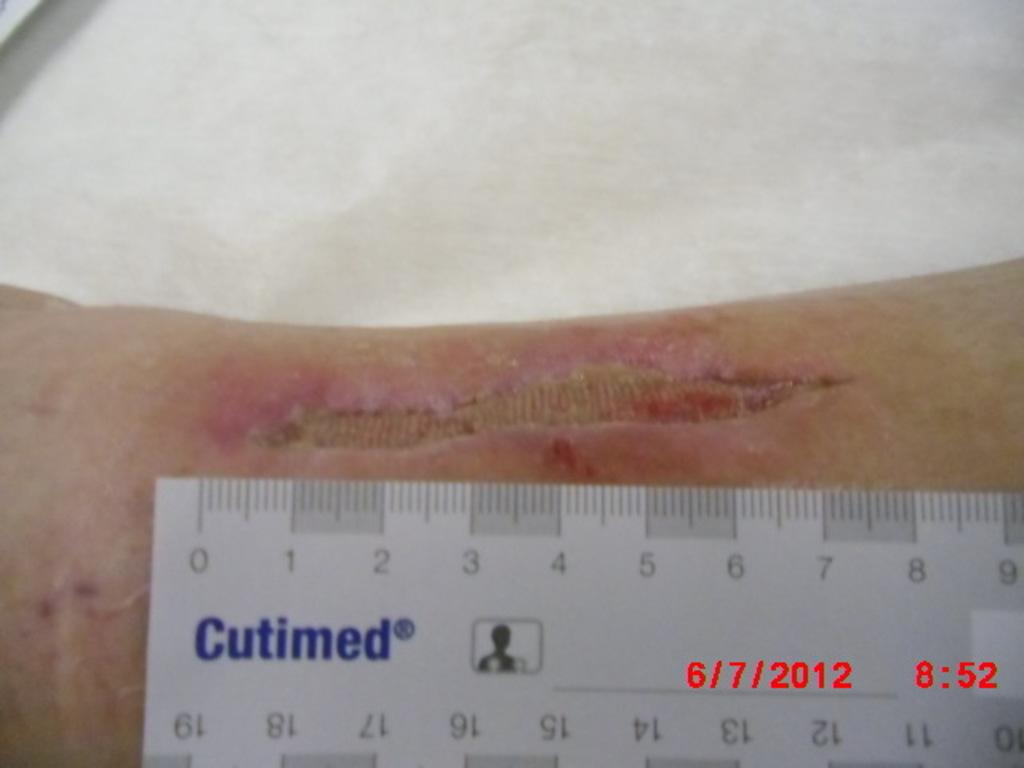What is the main object in the image? There is a scale ruler on an injured body part in the image. Is there any additional information provided in the image? Yes, there is a date and time at the bottom of the image. What type of apparel is the person wearing in the image? There is no person visible in the image, only a scale ruler on an injured body part. How many times does the person talk in the image? There is no person talking in the image, as it only shows a scale ruler on an injured body part and a date and time at the bottom. 